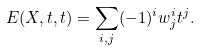<formula> <loc_0><loc_0><loc_500><loc_500>E ( X , t , t ) = \sum _ { i , j } ( - 1 ) ^ { i } w _ { j } ^ { i } t ^ { j } .</formula> 